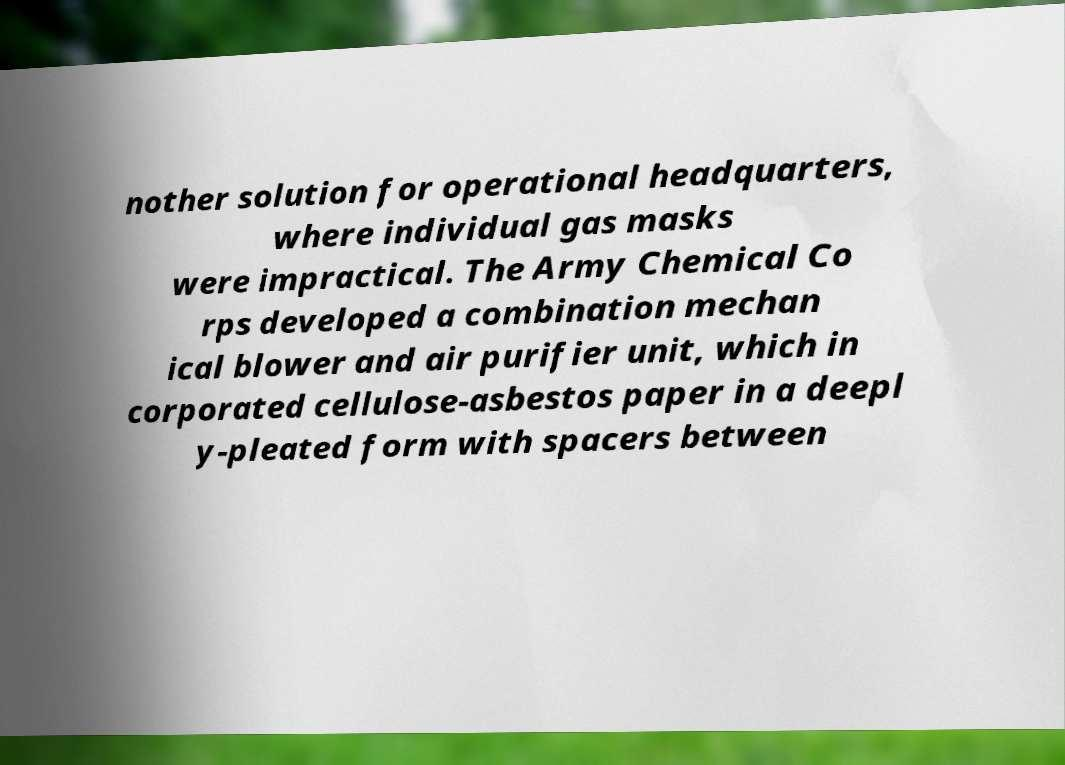What messages or text are displayed in this image? I need them in a readable, typed format. nother solution for operational headquarters, where individual gas masks were impractical. The Army Chemical Co rps developed a combination mechan ical blower and air purifier unit, which in corporated cellulose-asbestos paper in a deepl y-pleated form with spacers between 